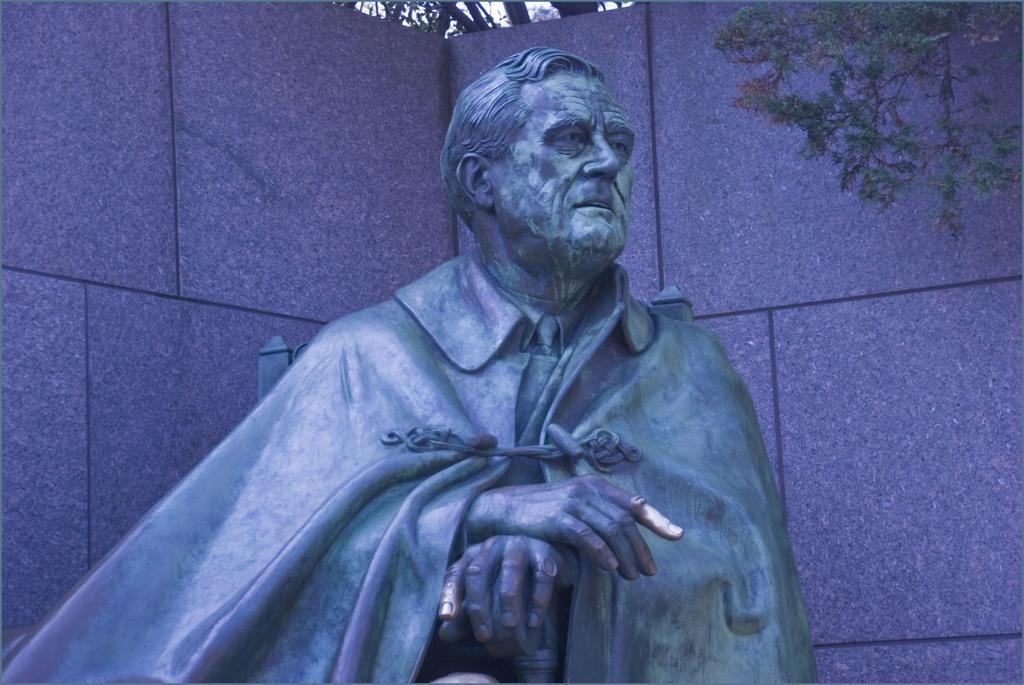In one or two sentences, can you explain what this image depicts? This is the statue of the man. Here is the wall. I think this is a tree with branches and leaves. 